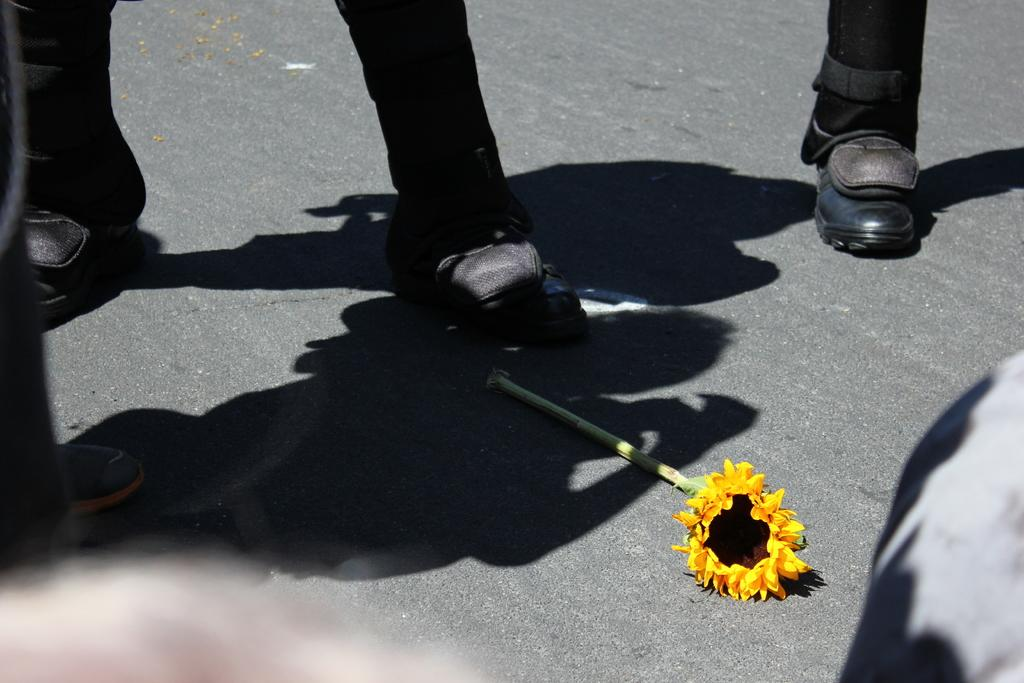What can be seen at the bottom of the image? There are legs of a person in the image. What is visible in the middle of the image? There are shadows of persons in the middle of the image. What type of object is present on the surface in the image? There is a flower on the surface in the image. What type of food is being advertised by the sign in the image? There is no sign present in the image, so it is not possible to determine what type of food might be advertised. 